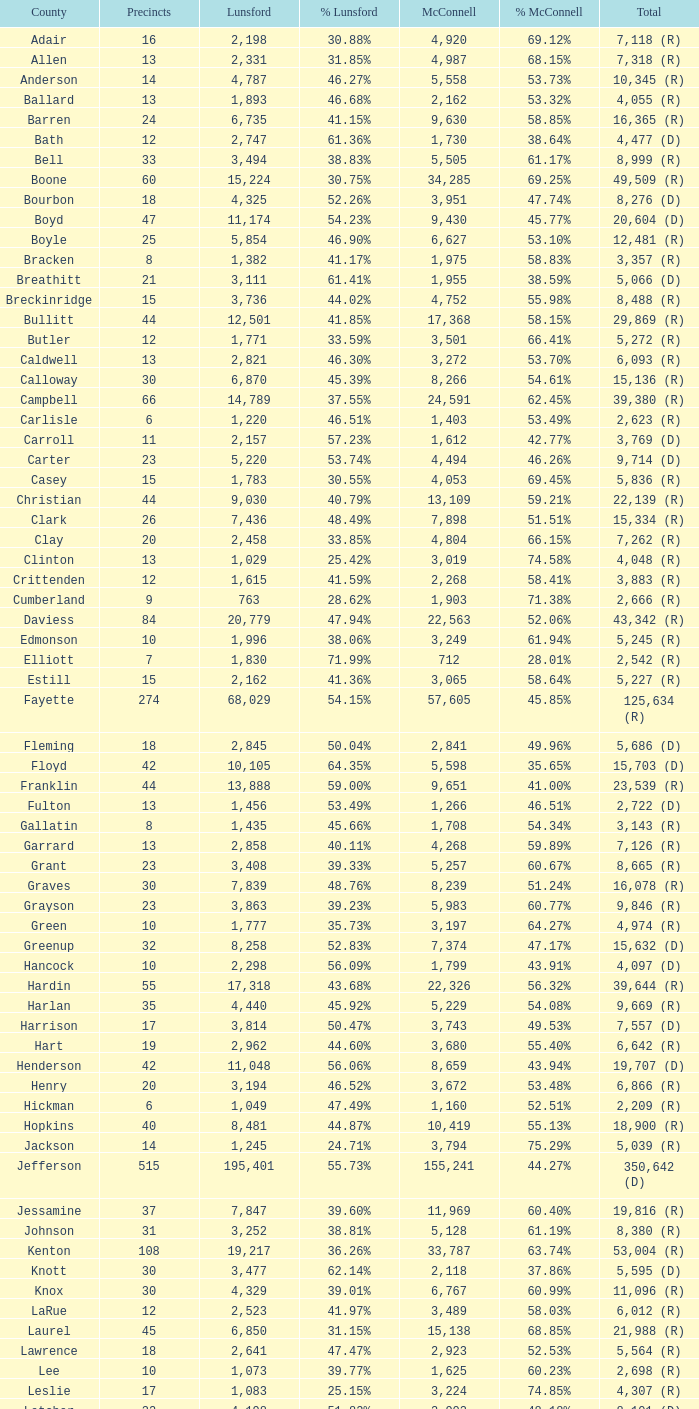What is the total number of Lunsford votes when the percentage of those votes is 33.85%? 1.0. 